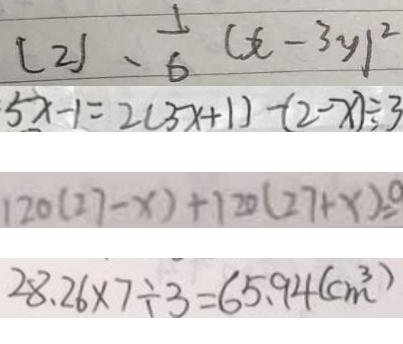Convert formula to latex. <formula><loc_0><loc_0><loc_500><loc_500>( 2 ) 、 \frac { 1 } { 6 } ( x - 3 y ) ^ { 2 } 
 5 x - 1 = 2 ( 3 x + 1 ) - ( 2 - x ) \div 3 
 1 2 0 ( 2 7 - x ) + 1 2 0 ( 2 7 + x ) = 0 
 2 8 . 2 6 \times 7 \div 3 = 6 5 . 9 4 ( c m ^ { 3 } )</formula> 